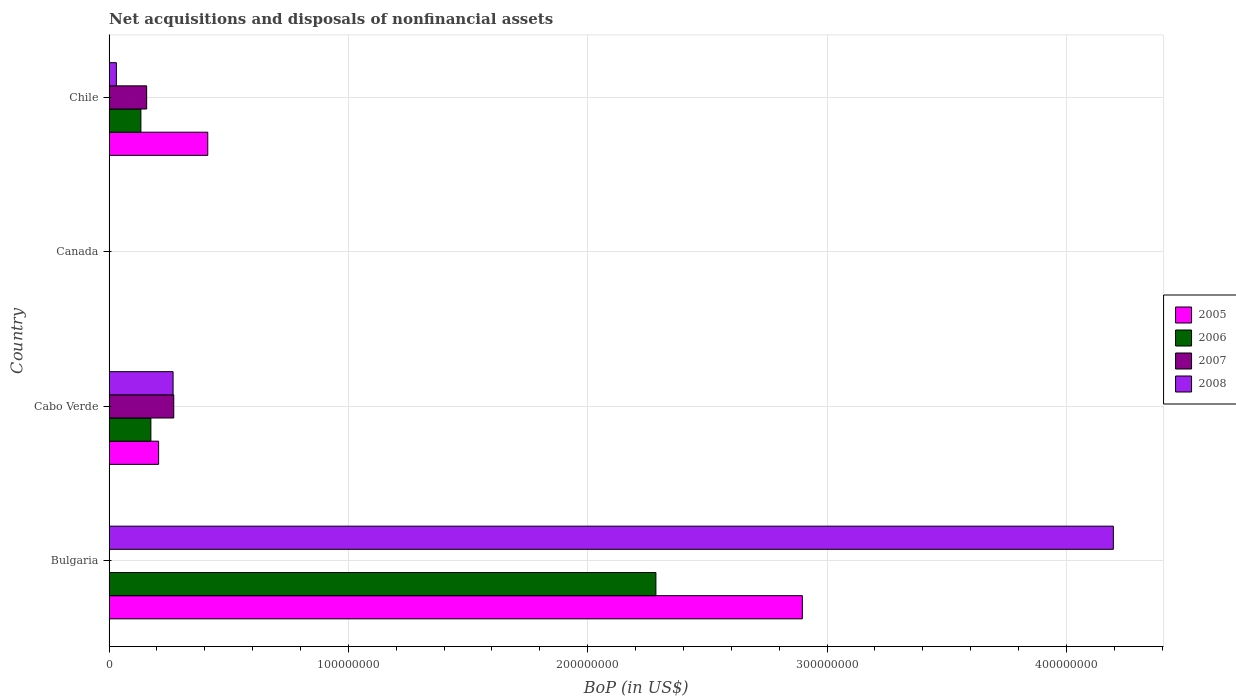Are the number of bars on each tick of the Y-axis equal?
Your answer should be very brief. No. How many bars are there on the 1st tick from the top?
Provide a short and direct response. 4. How many bars are there on the 4th tick from the bottom?
Keep it short and to the point. 4. What is the label of the 4th group of bars from the top?
Your response must be concise. Bulgaria. What is the Balance of Payments in 2007 in Chile?
Offer a very short reply. 1.57e+07. Across all countries, what is the maximum Balance of Payments in 2006?
Provide a short and direct response. 2.28e+08. What is the total Balance of Payments in 2008 in the graph?
Make the answer very short. 4.49e+08. What is the difference between the Balance of Payments in 2005 in Cabo Verde and that in Chile?
Your response must be concise. -2.05e+07. What is the difference between the Balance of Payments in 2007 in Chile and the Balance of Payments in 2008 in Canada?
Provide a short and direct response. 1.57e+07. What is the average Balance of Payments in 2005 per country?
Provide a succinct answer. 8.79e+07. What is the difference between the Balance of Payments in 2006 and Balance of Payments in 2005 in Bulgaria?
Keep it short and to the point. -6.12e+07. In how many countries, is the Balance of Payments in 2006 greater than 420000000 US$?
Ensure brevity in your answer.  0. What is the difference between the highest and the second highest Balance of Payments in 2005?
Offer a terse response. 2.48e+08. What is the difference between the highest and the lowest Balance of Payments in 2008?
Your answer should be compact. 4.20e+08. In how many countries, is the Balance of Payments in 2006 greater than the average Balance of Payments in 2006 taken over all countries?
Ensure brevity in your answer.  1. Is it the case that in every country, the sum of the Balance of Payments in 2005 and Balance of Payments in 2006 is greater than the sum of Balance of Payments in 2008 and Balance of Payments in 2007?
Your answer should be compact. No. Are all the bars in the graph horizontal?
Ensure brevity in your answer.  Yes. What is the difference between two consecutive major ticks on the X-axis?
Offer a terse response. 1.00e+08. Are the values on the major ticks of X-axis written in scientific E-notation?
Give a very brief answer. No. Does the graph contain grids?
Offer a terse response. Yes. Where does the legend appear in the graph?
Ensure brevity in your answer.  Center right. What is the title of the graph?
Give a very brief answer. Net acquisitions and disposals of nonfinancial assets. What is the label or title of the X-axis?
Your answer should be very brief. BoP (in US$). What is the BoP (in US$) in 2005 in Bulgaria?
Ensure brevity in your answer.  2.90e+08. What is the BoP (in US$) in 2006 in Bulgaria?
Provide a short and direct response. 2.28e+08. What is the BoP (in US$) in 2007 in Bulgaria?
Make the answer very short. 0. What is the BoP (in US$) in 2008 in Bulgaria?
Ensure brevity in your answer.  4.20e+08. What is the BoP (in US$) in 2005 in Cabo Verde?
Provide a short and direct response. 2.07e+07. What is the BoP (in US$) in 2006 in Cabo Verde?
Offer a terse response. 1.75e+07. What is the BoP (in US$) of 2007 in Cabo Verde?
Make the answer very short. 2.70e+07. What is the BoP (in US$) in 2008 in Cabo Verde?
Your answer should be compact. 2.67e+07. What is the BoP (in US$) of 2005 in Canada?
Give a very brief answer. 0. What is the BoP (in US$) in 2006 in Canada?
Provide a short and direct response. 0. What is the BoP (in US$) of 2007 in Canada?
Provide a short and direct response. 0. What is the BoP (in US$) of 2005 in Chile?
Your answer should be very brief. 4.12e+07. What is the BoP (in US$) of 2006 in Chile?
Provide a short and direct response. 1.33e+07. What is the BoP (in US$) of 2007 in Chile?
Provide a succinct answer. 1.57e+07. What is the BoP (in US$) in 2008 in Chile?
Make the answer very short. 3.06e+06. Across all countries, what is the maximum BoP (in US$) of 2005?
Offer a terse response. 2.90e+08. Across all countries, what is the maximum BoP (in US$) in 2006?
Your response must be concise. 2.28e+08. Across all countries, what is the maximum BoP (in US$) of 2007?
Your answer should be very brief. 2.70e+07. Across all countries, what is the maximum BoP (in US$) in 2008?
Keep it short and to the point. 4.20e+08. Across all countries, what is the minimum BoP (in US$) of 2005?
Give a very brief answer. 0. What is the total BoP (in US$) of 2005 in the graph?
Your response must be concise. 3.52e+08. What is the total BoP (in US$) of 2006 in the graph?
Ensure brevity in your answer.  2.59e+08. What is the total BoP (in US$) in 2007 in the graph?
Ensure brevity in your answer.  4.27e+07. What is the total BoP (in US$) in 2008 in the graph?
Offer a very short reply. 4.49e+08. What is the difference between the BoP (in US$) in 2005 in Bulgaria and that in Cabo Verde?
Make the answer very short. 2.69e+08. What is the difference between the BoP (in US$) of 2006 in Bulgaria and that in Cabo Verde?
Provide a succinct answer. 2.11e+08. What is the difference between the BoP (in US$) in 2008 in Bulgaria and that in Cabo Verde?
Keep it short and to the point. 3.93e+08. What is the difference between the BoP (in US$) in 2005 in Bulgaria and that in Chile?
Your answer should be compact. 2.48e+08. What is the difference between the BoP (in US$) of 2006 in Bulgaria and that in Chile?
Provide a succinct answer. 2.15e+08. What is the difference between the BoP (in US$) of 2008 in Bulgaria and that in Chile?
Offer a terse response. 4.17e+08. What is the difference between the BoP (in US$) of 2005 in Cabo Verde and that in Chile?
Ensure brevity in your answer.  -2.05e+07. What is the difference between the BoP (in US$) of 2006 in Cabo Verde and that in Chile?
Your answer should be compact. 4.17e+06. What is the difference between the BoP (in US$) of 2007 in Cabo Verde and that in Chile?
Offer a terse response. 1.13e+07. What is the difference between the BoP (in US$) in 2008 in Cabo Verde and that in Chile?
Make the answer very short. 2.37e+07. What is the difference between the BoP (in US$) in 2005 in Bulgaria and the BoP (in US$) in 2006 in Cabo Verde?
Provide a short and direct response. 2.72e+08. What is the difference between the BoP (in US$) of 2005 in Bulgaria and the BoP (in US$) of 2007 in Cabo Verde?
Provide a short and direct response. 2.63e+08. What is the difference between the BoP (in US$) of 2005 in Bulgaria and the BoP (in US$) of 2008 in Cabo Verde?
Keep it short and to the point. 2.63e+08. What is the difference between the BoP (in US$) of 2006 in Bulgaria and the BoP (in US$) of 2007 in Cabo Verde?
Your answer should be very brief. 2.01e+08. What is the difference between the BoP (in US$) of 2006 in Bulgaria and the BoP (in US$) of 2008 in Cabo Verde?
Offer a terse response. 2.02e+08. What is the difference between the BoP (in US$) in 2005 in Bulgaria and the BoP (in US$) in 2006 in Chile?
Ensure brevity in your answer.  2.76e+08. What is the difference between the BoP (in US$) of 2005 in Bulgaria and the BoP (in US$) of 2007 in Chile?
Make the answer very short. 2.74e+08. What is the difference between the BoP (in US$) in 2005 in Bulgaria and the BoP (in US$) in 2008 in Chile?
Offer a terse response. 2.87e+08. What is the difference between the BoP (in US$) in 2006 in Bulgaria and the BoP (in US$) in 2007 in Chile?
Make the answer very short. 2.13e+08. What is the difference between the BoP (in US$) of 2006 in Bulgaria and the BoP (in US$) of 2008 in Chile?
Keep it short and to the point. 2.25e+08. What is the difference between the BoP (in US$) of 2005 in Cabo Verde and the BoP (in US$) of 2006 in Chile?
Your answer should be very brief. 7.41e+06. What is the difference between the BoP (in US$) of 2005 in Cabo Verde and the BoP (in US$) of 2007 in Chile?
Your response must be concise. 5.00e+06. What is the difference between the BoP (in US$) of 2005 in Cabo Verde and the BoP (in US$) of 2008 in Chile?
Offer a very short reply. 1.77e+07. What is the difference between the BoP (in US$) of 2006 in Cabo Verde and the BoP (in US$) of 2007 in Chile?
Give a very brief answer. 1.76e+06. What is the difference between the BoP (in US$) of 2006 in Cabo Verde and the BoP (in US$) of 2008 in Chile?
Offer a terse response. 1.44e+07. What is the difference between the BoP (in US$) in 2007 in Cabo Verde and the BoP (in US$) in 2008 in Chile?
Offer a very short reply. 2.40e+07. What is the average BoP (in US$) of 2005 per country?
Ensure brevity in your answer.  8.79e+07. What is the average BoP (in US$) of 2006 per country?
Provide a succinct answer. 6.48e+07. What is the average BoP (in US$) of 2007 per country?
Give a very brief answer. 1.07e+07. What is the average BoP (in US$) in 2008 per country?
Your answer should be very brief. 1.12e+08. What is the difference between the BoP (in US$) of 2005 and BoP (in US$) of 2006 in Bulgaria?
Make the answer very short. 6.12e+07. What is the difference between the BoP (in US$) in 2005 and BoP (in US$) in 2008 in Bulgaria?
Keep it short and to the point. -1.30e+08. What is the difference between the BoP (in US$) of 2006 and BoP (in US$) of 2008 in Bulgaria?
Your answer should be compact. -1.91e+08. What is the difference between the BoP (in US$) of 2005 and BoP (in US$) of 2006 in Cabo Verde?
Keep it short and to the point. 3.24e+06. What is the difference between the BoP (in US$) in 2005 and BoP (in US$) in 2007 in Cabo Verde?
Keep it short and to the point. -6.32e+06. What is the difference between the BoP (in US$) in 2005 and BoP (in US$) in 2008 in Cabo Verde?
Your answer should be very brief. -6.04e+06. What is the difference between the BoP (in US$) in 2006 and BoP (in US$) in 2007 in Cabo Verde?
Provide a short and direct response. -9.56e+06. What is the difference between the BoP (in US$) of 2006 and BoP (in US$) of 2008 in Cabo Verde?
Ensure brevity in your answer.  -9.28e+06. What is the difference between the BoP (in US$) in 2007 and BoP (in US$) in 2008 in Cabo Verde?
Make the answer very short. 2.85e+05. What is the difference between the BoP (in US$) in 2005 and BoP (in US$) in 2006 in Chile?
Offer a terse response. 2.79e+07. What is the difference between the BoP (in US$) of 2005 and BoP (in US$) of 2007 in Chile?
Offer a very short reply. 2.55e+07. What is the difference between the BoP (in US$) in 2005 and BoP (in US$) in 2008 in Chile?
Ensure brevity in your answer.  3.82e+07. What is the difference between the BoP (in US$) of 2006 and BoP (in US$) of 2007 in Chile?
Keep it short and to the point. -2.41e+06. What is the difference between the BoP (in US$) in 2006 and BoP (in US$) in 2008 in Chile?
Your answer should be compact. 1.02e+07. What is the difference between the BoP (in US$) in 2007 and BoP (in US$) in 2008 in Chile?
Provide a succinct answer. 1.27e+07. What is the ratio of the BoP (in US$) in 2005 in Bulgaria to that in Cabo Verde?
Your answer should be very brief. 13.99. What is the ratio of the BoP (in US$) in 2006 in Bulgaria to that in Cabo Verde?
Offer a very short reply. 13.08. What is the ratio of the BoP (in US$) of 2008 in Bulgaria to that in Cabo Verde?
Keep it short and to the point. 15.69. What is the ratio of the BoP (in US$) in 2005 in Bulgaria to that in Chile?
Your response must be concise. 7.02. What is the ratio of the BoP (in US$) in 2006 in Bulgaria to that in Chile?
Offer a terse response. 17.18. What is the ratio of the BoP (in US$) in 2008 in Bulgaria to that in Chile?
Give a very brief answer. 137.31. What is the ratio of the BoP (in US$) of 2005 in Cabo Verde to that in Chile?
Keep it short and to the point. 0.5. What is the ratio of the BoP (in US$) of 2006 in Cabo Verde to that in Chile?
Ensure brevity in your answer.  1.31. What is the ratio of the BoP (in US$) of 2007 in Cabo Verde to that in Chile?
Keep it short and to the point. 1.72. What is the ratio of the BoP (in US$) in 2008 in Cabo Verde to that in Chile?
Your response must be concise. 8.75. What is the difference between the highest and the second highest BoP (in US$) of 2005?
Your response must be concise. 2.48e+08. What is the difference between the highest and the second highest BoP (in US$) in 2006?
Give a very brief answer. 2.11e+08. What is the difference between the highest and the second highest BoP (in US$) of 2008?
Offer a terse response. 3.93e+08. What is the difference between the highest and the lowest BoP (in US$) of 2005?
Ensure brevity in your answer.  2.90e+08. What is the difference between the highest and the lowest BoP (in US$) in 2006?
Offer a terse response. 2.28e+08. What is the difference between the highest and the lowest BoP (in US$) in 2007?
Offer a very short reply. 2.70e+07. What is the difference between the highest and the lowest BoP (in US$) in 2008?
Give a very brief answer. 4.20e+08. 